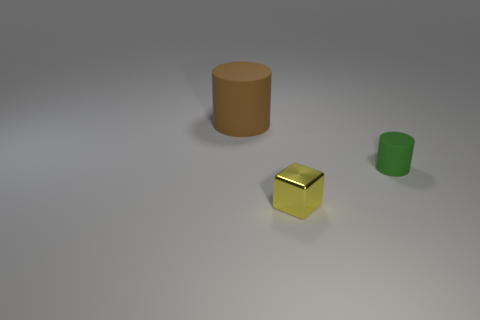Are there any other things of the same color as the small metallic thing?
Ensure brevity in your answer.  No. What material is the brown cylinder?
Keep it short and to the point. Rubber. What number of green cylinders are to the left of the tiny block?
Your answer should be very brief. 0. Are there fewer brown matte cylinders to the right of the brown rubber thing than green rubber objects?
Your response must be concise. Yes. The small rubber cylinder is what color?
Provide a short and direct response. Green. What color is the other rubber object that is the same shape as the big object?
Your answer should be very brief. Green. How many big objects are either green cylinders or gray spheres?
Offer a terse response. 0. What size is the cylinder in front of the big brown rubber cylinder?
Your answer should be very brief. Small. There is a object in front of the small green rubber cylinder; how many brown matte things are behind it?
Keep it short and to the point. 1. What number of green things are made of the same material as the big brown thing?
Your answer should be compact. 1. 